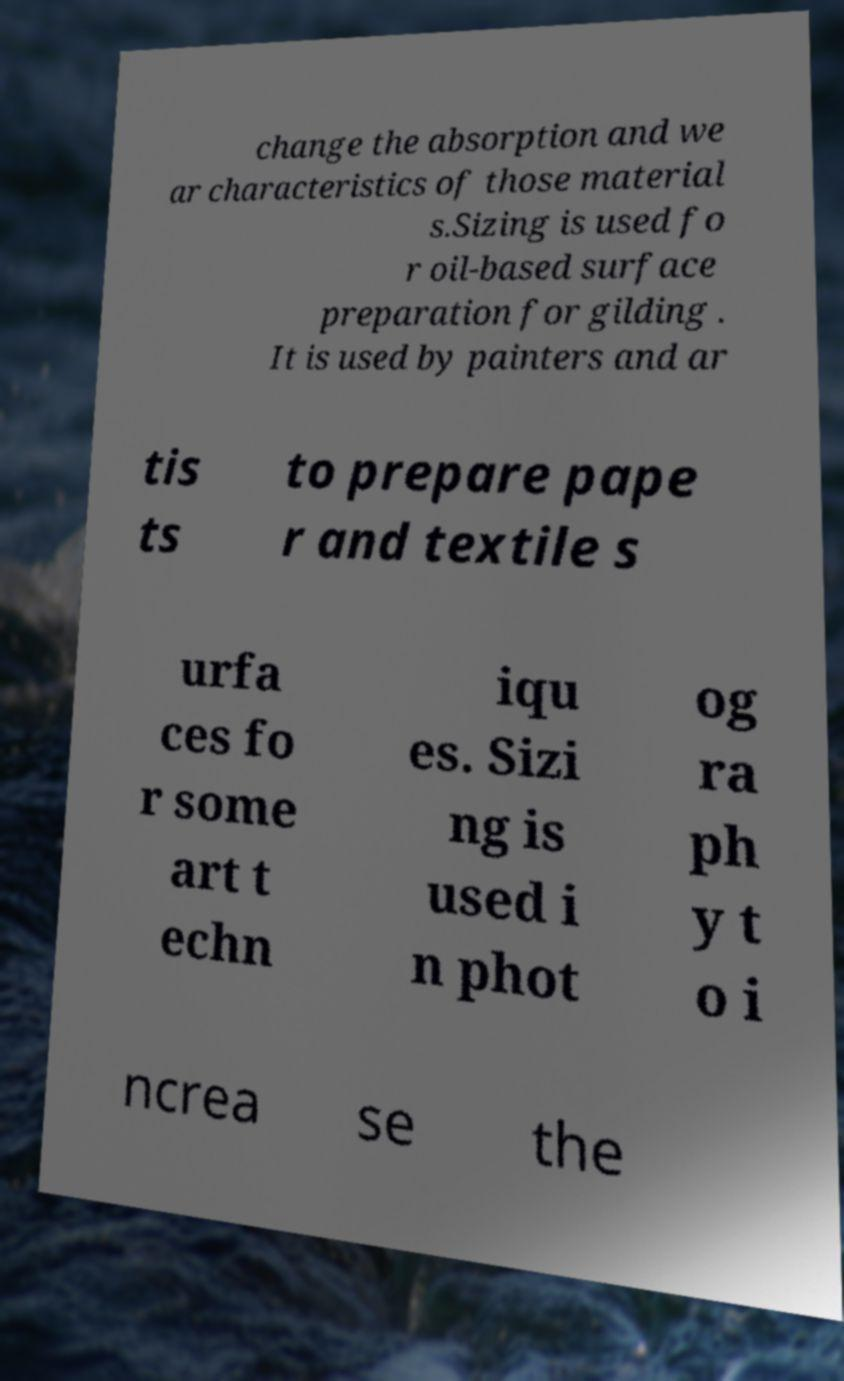I need the written content from this picture converted into text. Can you do that? change the absorption and we ar characteristics of those material s.Sizing is used fo r oil-based surface preparation for gilding . It is used by painters and ar tis ts to prepare pape r and textile s urfa ces fo r some art t echn iqu es. Sizi ng is used i n phot og ra ph y t o i ncrea se the 